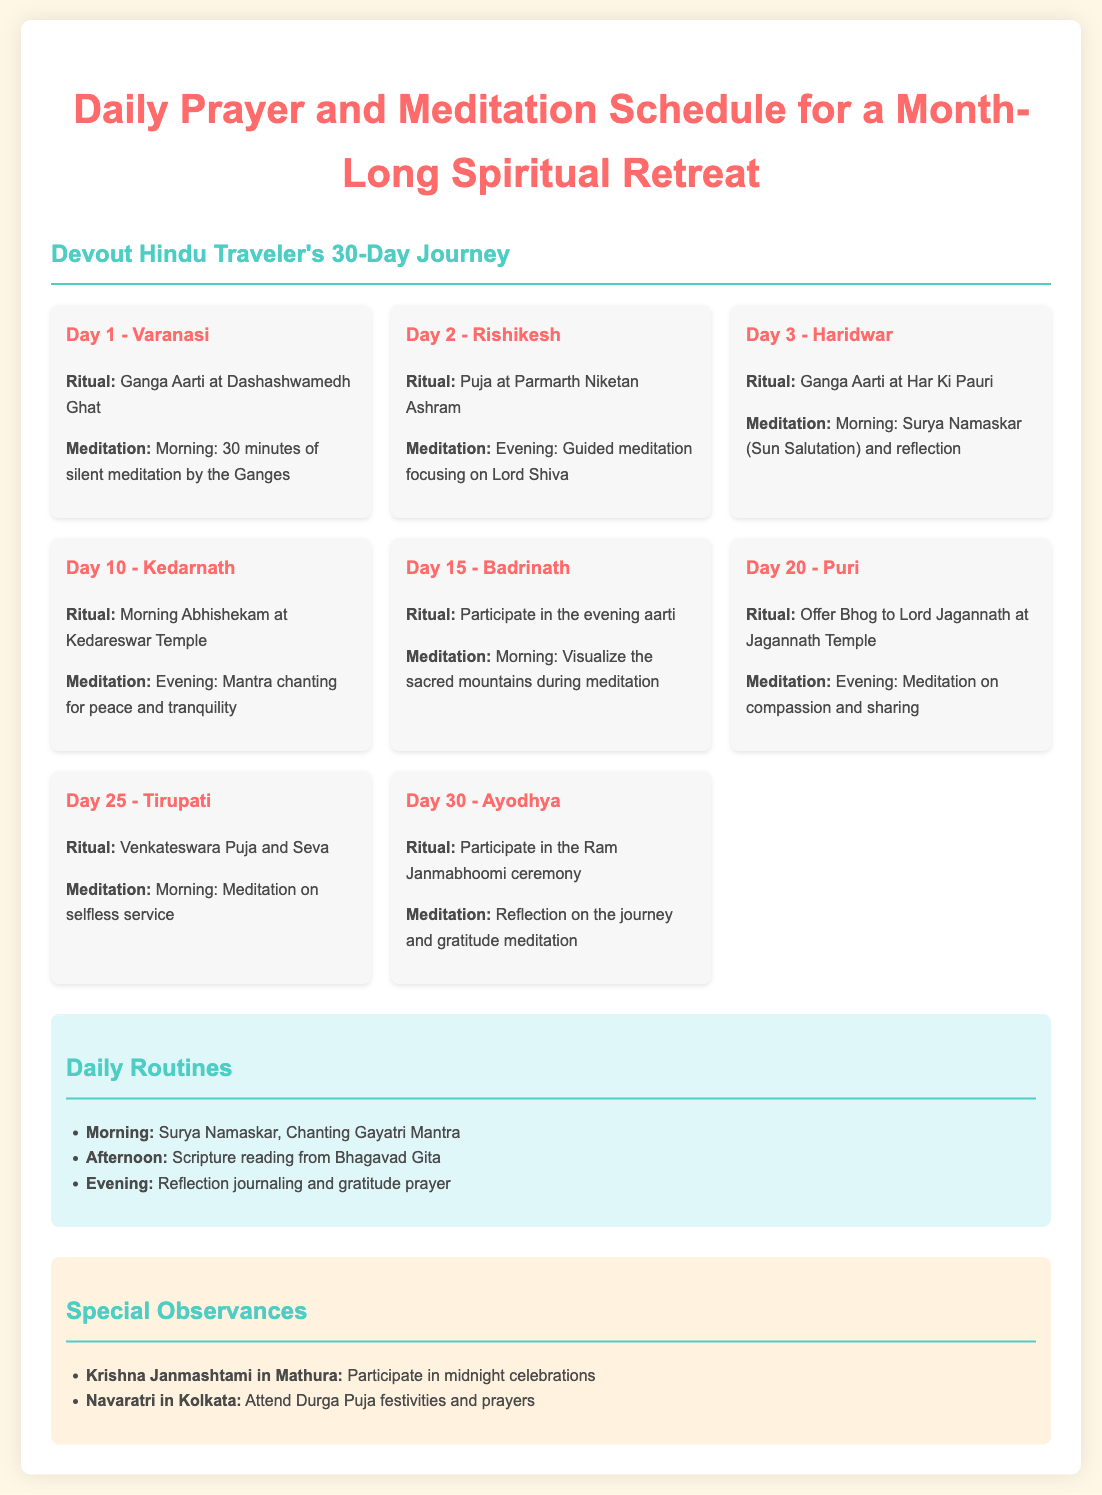What is the location for Day 1? The location listed for Day 1 is Varanasi.
Answer: Varanasi What ritual is performed on Day 2? The document states the ritual for Day 2 is Puja at Parmarth Niketan Ashram.
Answer: Puja at Parmarth Niketan Ashram How long is the silent meditation on Day 1? The silent meditation on Day 1 is specified to be 30 minutes long.
Answer: 30 minutes What is the special observance in Mathura? The special observance in Mathura is for Krishna Janmashtami where participants celebrate at midnight.
Answer: Participate in midnight celebrations Which day features meditation on selfless service? The day that features meditation on selfless service is Day 25.
Answer: Day 25 What is a daily routine activity in the morning? The daily routine activity in the morning includes Surya Namaskar and chanting the Gayatri Mantra.
Answer: Surya Namaskar, Chanting Gayatri Mantra What meditation technique is practiced on Day 10? Day 10 includes evening mantra chanting for peace and tranquility as the meditation technique.
Answer: Mantra chanting for peace and tranquility What is included in the daily routine during the afternoon? The daily routine during the afternoon involves scripture reading from the Bhagavad Gita.
Answer: Scripture reading from Bhagavad Gita 